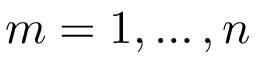<formula> <loc_0><loc_0><loc_500><loc_500>m = 1 , \dots , n</formula> 